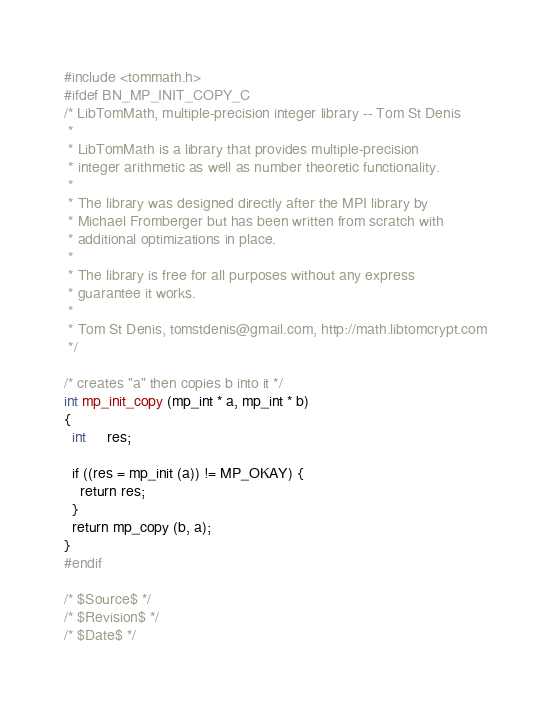Convert code to text. <code><loc_0><loc_0><loc_500><loc_500><_C_>#include <tommath.h>
#ifdef BN_MP_INIT_COPY_C
/* LibTomMath, multiple-precision integer library -- Tom St Denis
 *
 * LibTomMath is a library that provides multiple-precision
 * integer arithmetic as well as number theoretic functionality.
 *
 * The library was designed directly after the MPI library by
 * Michael Fromberger but has been written from scratch with
 * additional optimizations in place.
 *
 * The library is free for all purposes without any express
 * guarantee it works.
 *
 * Tom St Denis, tomstdenis@gmail.com, http://math.libtomcrypt.com
 */

/* creates "a" then copies b into it */
int mp_init_copy (mp_int * a, mp_int * b)
{
  int     res;

  if ((res = mp_init (a)) != MP_OKAY) {
    return res;
  }
  return mp_copy (b, a);
}
#endif

/* $Source$ */
/* $Revision$ */
/* $Date$ */
</code> 